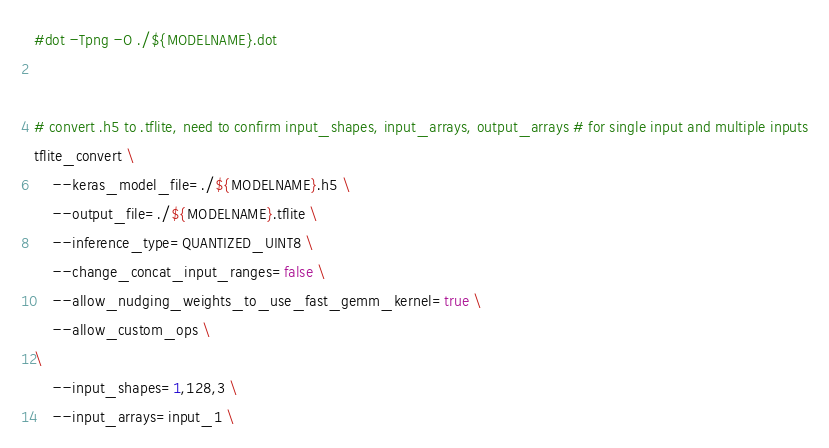Convert code to text. <code><loc_0><loc_0><loc_500><loc_500><_Bash_>#dot -Tpng -O ./${MODELNAME}.dot


# convert .h5 to .tflite, need to confirm input_shapes, input_arrays, output_arrays # for single input and multiple inputs
tflite_convert \
    --keras_model_file=./${MODELNAME}.h5 \
    --output_file=./${MODELNAME}.tflite \
    --inference_type=QUANTIZED_UINT8 \
    --change_concat_input_ranges=false \
    --allow_nudging_weights_to_use_fast_gemm_kernel=true \
    --allow_custom_ops \
\
    --input_shapes=1,128,3 \
    --input_arrays=input_1 \</code> 